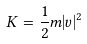<formula> <loc_0><loc_0><loc_500><loc_500>K = { \frac { 1 } { 2 } } m | v | ^ { 2 }</formula> 